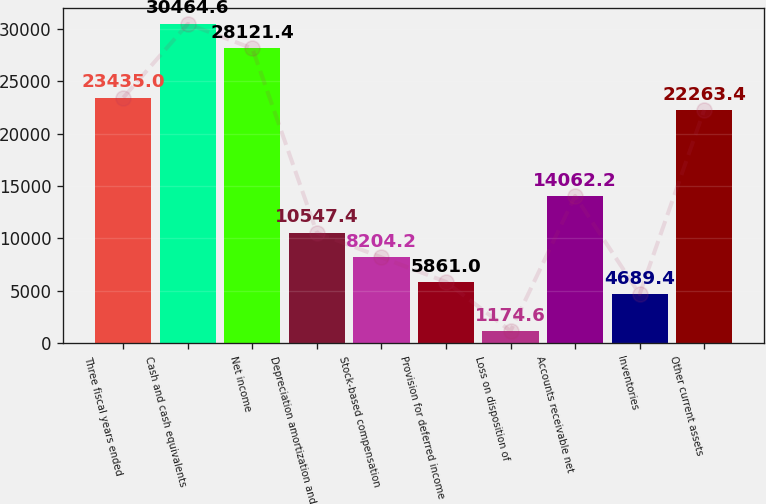<chart> <loc_0><loc_0><loc_500><loc_500><bar_chart><fcel>Three fiscal years ended<fcel>Cash and cash equivalents<fcel>Net income<fcel>Depreciation amortization and<fcel>Stock-based compensation<fcel>Provision for deferred income<fcel>Loss on disposition of<fcel>Accounts receivable net<fcel>Inventories<fcel>Other current assets<nl><fcel>23435<fcel>30464.6<fcel>28121.4<fcel>10547.4<fcel>8204.2<fcel>5861<fcel>1174.6<fcel>14062.2<fcel>4689.4<fcel>22263.4<nl></chart> 